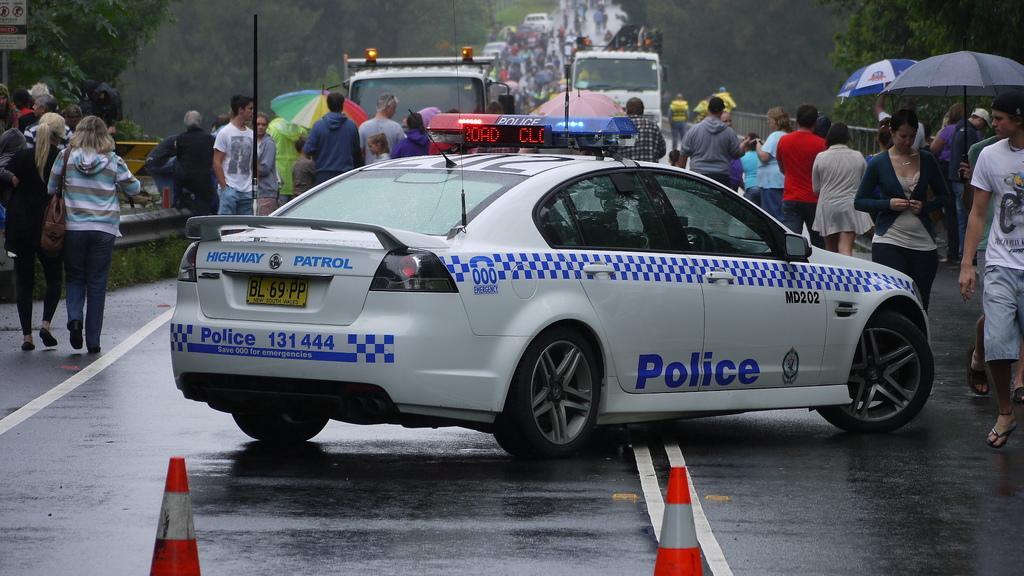Describe this image in one or two sentences. In this image in the center there are some people, and there are some vehicles and some of them are holding umbrellas and walking. And an the bottom there is road and barricades, and in the background there are trees, poles, boards and railing. 